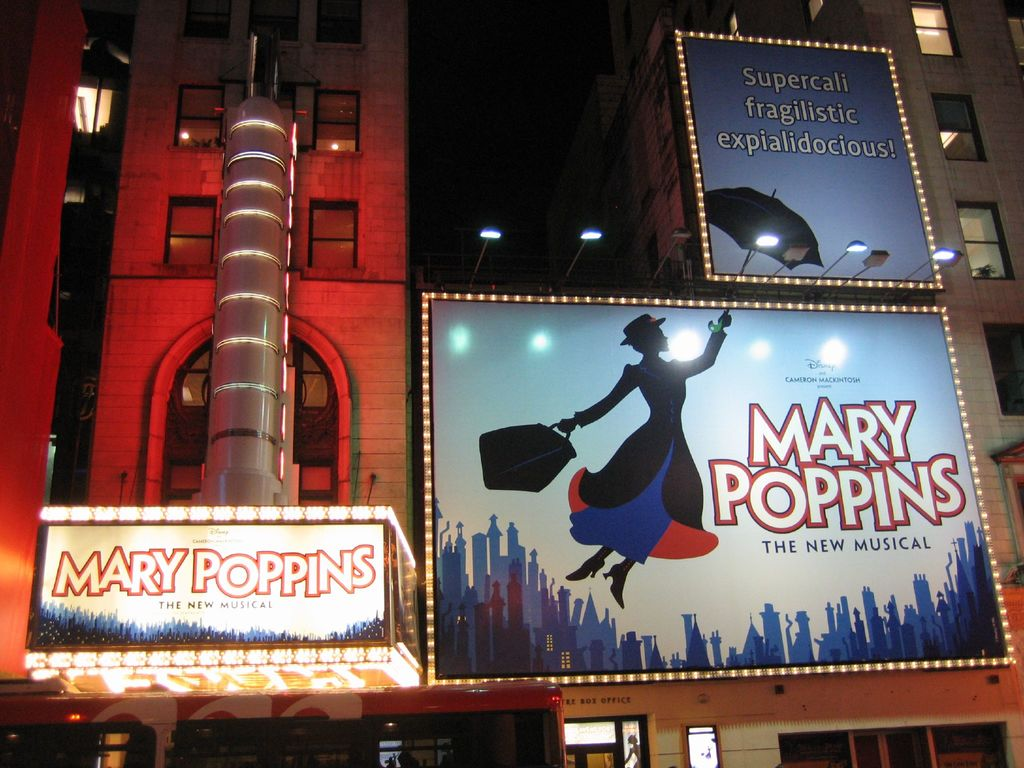Can you describe the architectural style of the theater building shown in the image? The theater building in the image exhibits a classic mid-20th century architectural style, characterized by its use of red brickwork and streamlined Art Deco elements. The vertical silver column on the left side of the facade adds a modern touch, suggesting a style that marries traditional theater architecture with contemporary enhancements that might have been added to preserve its historical value while meeting modern standards. 